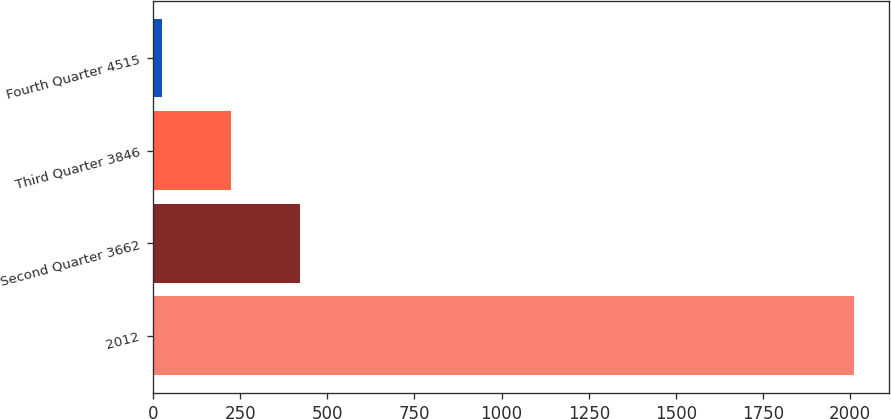Convert chart. <chart><loc_0><loc_0><loc_500><loc_500><bar_chart><fcel>2012<fcel>Second Quarter 3662<fcel>Third Quarter 3846<fcel>Fourth Quarter 4515<nl><fcel>2011<fcel>422.64<fcel>224.1<fcel>25.55<nl></chart> 